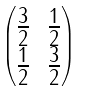Convert formula to latex. <formula><loc_0><loc_0><loc_500><loc_500>\begin{pmatrix} \frac { 3 } { 2 } & \frac { 1 } { 2 } \\ \frac { 1 } { 2 } & \frac { 3 } { 2 } \end{pmatrix}</formula> 